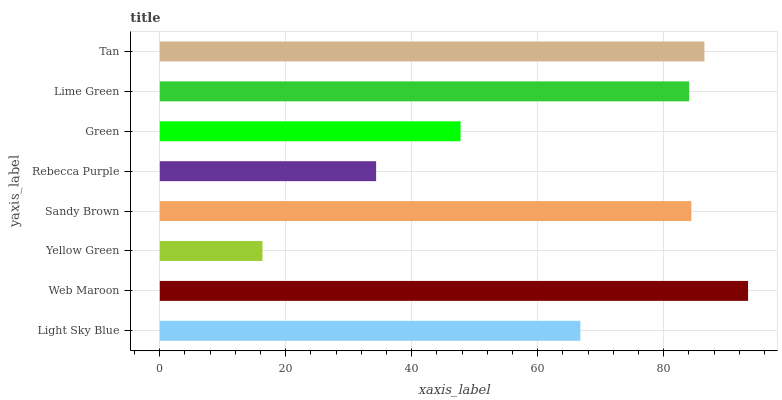Is Yellow Green the minimum?
Answer yes or no. Yes. Is Web Maroon the maximum?
Answer yes or no. Yes. Is Web Maroon the minimum?
Answer yes or no. No. Is Yellow Green the maximum?
Answer yes or no. No. Is Web Maroon greater than Yellow Green?
Answer yes or no. Yes. Is Yellow Green less than Web Maroon?
Answer yes or no. Yes. Is Yellow Green greater than Web Maroon?
Answer yes or no. No. Is Web Maroon less than Yellow Green?
Answer yes or no. No. Is Lime Green the high median?
Answer yes or no. Yes. Is Light Sky Blue the low median?
Answer yes or no. Yes. Is Yellow Green the high median?
Answer yes or no. No. Is Web Maroon the low median?
Answer yes or no. No. 